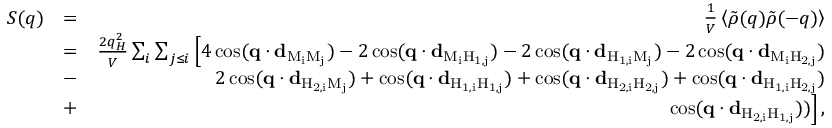<formula> <loc_0><loc_0><loc_500><loc_500>\begin{array} { r l r } { S ( q ) } & { = } & { \frac { 1 } { V } \left \langle \tilde { \rho } ( q ) \tilde { \rho } ( - q ) \right \rangle } \\ & { = } & { \frac { 2 q _ { H } ^ { 2 } } { V } \sum _ { i } \sum _ { j \leq i } \left [ 4 \cos ( q \cdot d _ { M _ { i } M _ { j } } ) - 2 \cos ( q \cdot d _ { M _ { i } H _ { 1 , j } } ) - 2 \cos ( q \cdot d _ { H _ { 1 , i } M _ { j } } ) - 2 \cos ( q \cdot d _ { M _ { i } H _ { 2 , j } } ) } \\ & { - } & { 2 \cos ( q \cdot d _ { H _ { 2 , i } M _ { j } } ) + \cos ( q \cdot d _ { H _ { 1 , i } H _ { 1 , j } } ) + \cos ( q \cdot d _ { H _ { 2 , i } H _ { 2 , j } } ) + \cos ( q \cdot d _ { H _ { 1 , i } H _ { 2 , j } } ) } \\ & { + } & { \cos ( q \cdot d _ { H _ { 2 , i } H _ { 1 , j } } ) ) \right ] \, , } \end{array}</formula> 